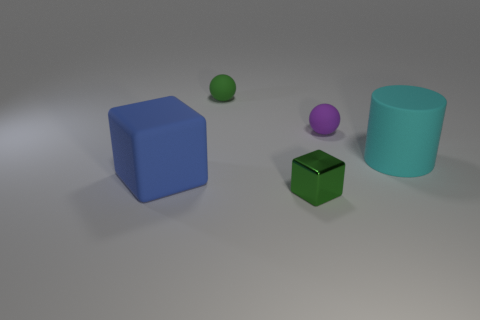Add 2 green spheres. How many objects exist? 7 Subtract all balls. How many objects are left? 3 Add 4 blue balls. How many blue balls exist? 4 Subtract 0 gray cylinders. How many objects are left? 5 Subtract all big cyan rubber cylinders. Subtract all small metal blocks. How many objects are left? 3 Add 1 blue cubes. How many blue cubes are left? 2 